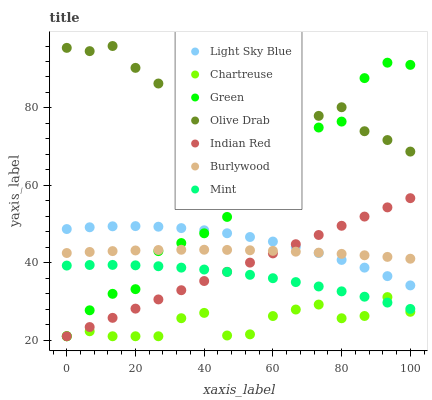Does Chartreuse have the minimum area under the curve?
Answer yes or no. Yes. Does Olive Drab have the maximum area under the curve?
Answer yes or no. Yes. Does Light Sky Blue have the minimum area under the curve?
Answer yes or no. No. Does Light Sky Blue have the maximum area under the curve?
Answer yes or no. No. Is Indian Red the smoothest?
Answer yes or no. Yes. Is Olive Drab the roughest?
Answer yes or no. Yes. Is Chartreuse the smoothest?
Answer yes or no. No. Is Chartreuse the roughest?
Answer yes or no. No. Does Chartreuse have the lowest value?
Answer yes or no. Yes. Does Light Sky Blue have the lowest value?
Answer yes or no. No. Does Olive Drab have the highest value?
Answer yes or no. Yes. Does Light Sky Blue have the highest value?
Answer yes or no. No. Is Burlywood less than Olive Drab?
Answer yes or no. Yes. Is Olive Drab greater than Indian Red?
Answer yes or no. Yes. Does Chartreuse intersect Green?
Answer yes or no. Yes. Is Chartreuse less than Green?
Answer yes or no. No. Is Chartreuse greater than Green?
Answer yes or no. No. Does Burlywood intersect Olive Drab?
Answer yes or no. No. 